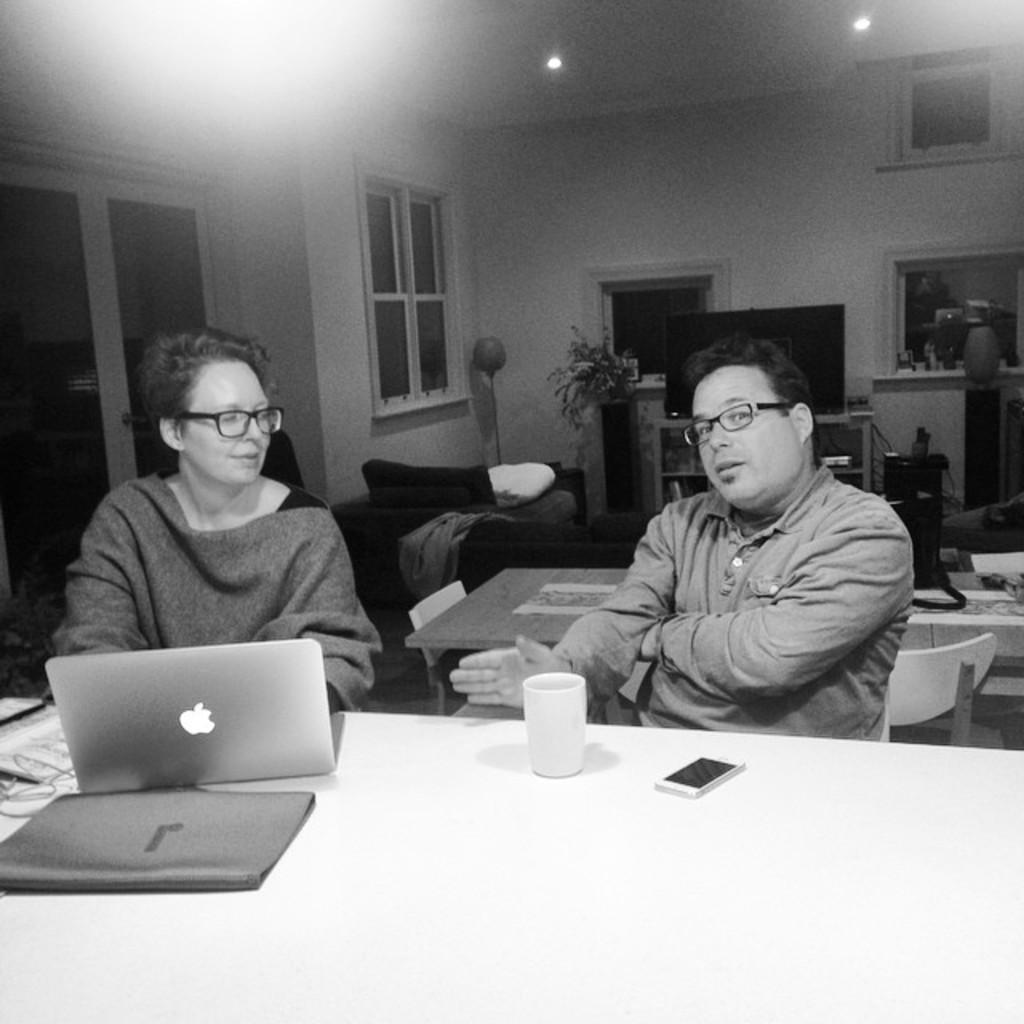What are the couple doing in the image? The couple is sitting in chairs at a table. What electronic device is on the table? There is a laptop on the table. What type of drink container is on the table? There is a glass on the table. What other electronic device is on the table? There is a mobile phone on the table. What can be seen behind the couple? There is a door behind the couple. What furniture is visible in the background? There is a sofa and a table in the background. What type of entertainment device is in the background? There is a TV in the background. What type of bear can be seen in the image? There is no bear present in the image. 